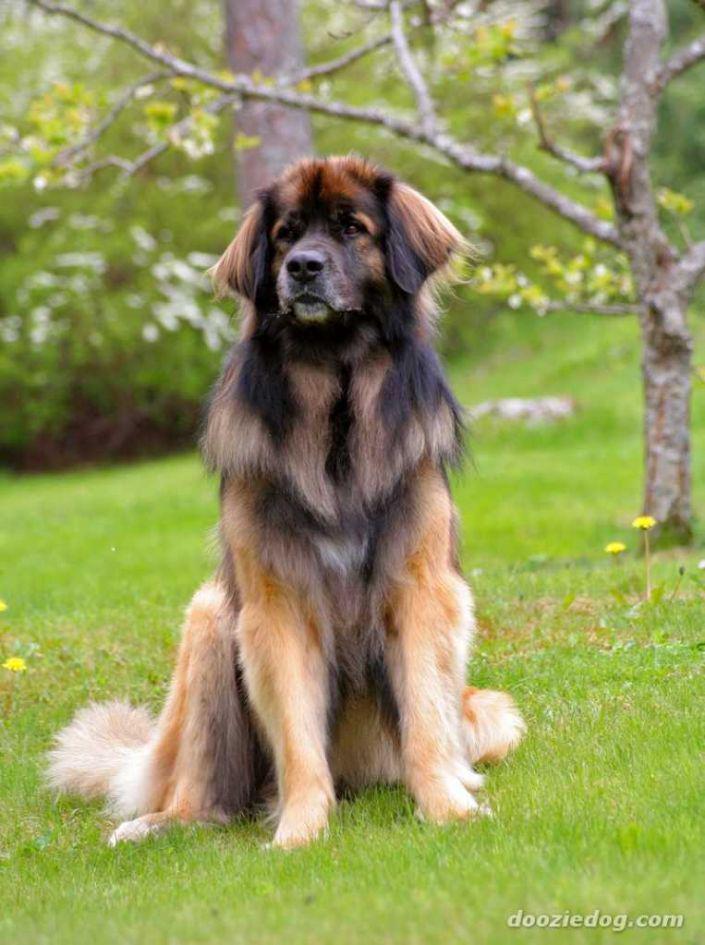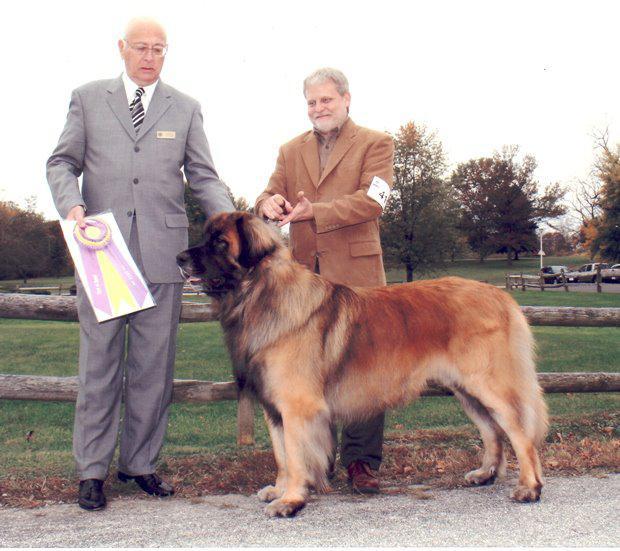The first image is the image on the left, the second image is the image on the right. For the images shown, is this caption "Only one image is of a dog with no people present." true? Answer yes or no. Yes. The first image is the image on the left, the second image is the image on the right. Examine the images to the left and right. Is the description "There is one adult human in the image on the left" accurate? Answer yes or no. No. 